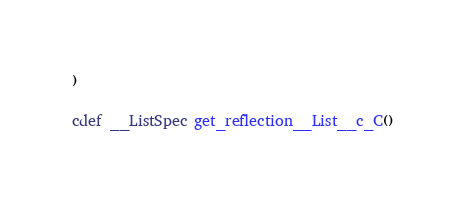<code> <loc_0><loc_0><loc_500><loc_500><_Cython_>)

cdef __ListSpec get_reflection__List__c_C()
</code> 